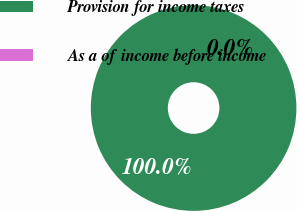Convert chart. <chart><loc_0><loc_0><loc_500><loc_500><pie_chart><fcel>Provision for income taxes<fcel>As a of income before income<nl><fcel>100.0%<fcel>0.0%<nl></chart> 